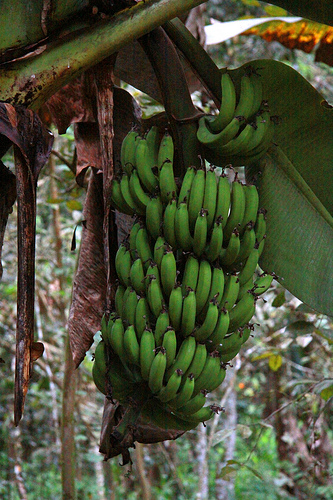Please provide the bounding box coordinate of the region this sentence describes: Stem of the banana. The coordinates framing the stem of the banana are [0.47, 0.1, 0.56, 0.24]. 